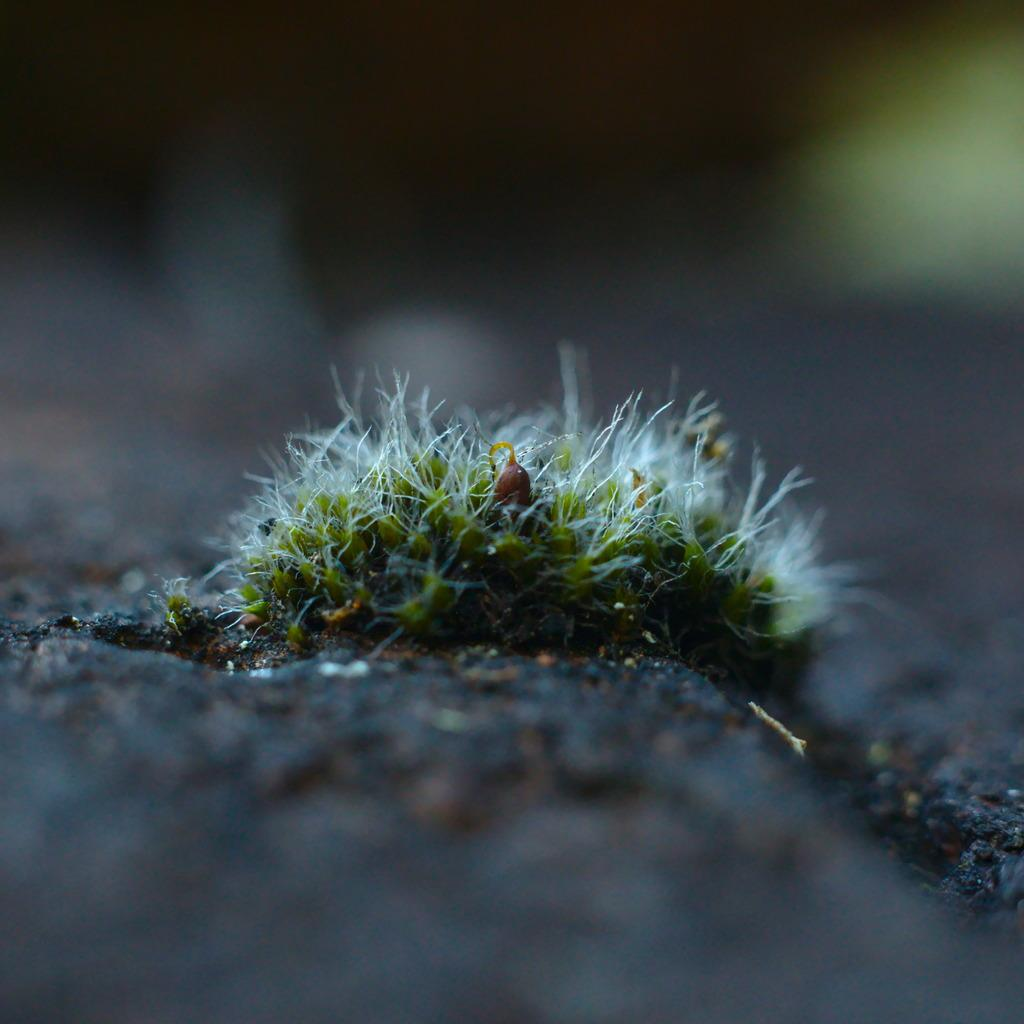What type of vegetation can be seen in the image? There is grass in the image. What color is the grass? The grass is green in color. Can you describe the background of the image? The background of the image is blurred. What type of cracker is being used during the operation in the image? There is no operation or cracker present in the image; it features grass with a blurred background. 